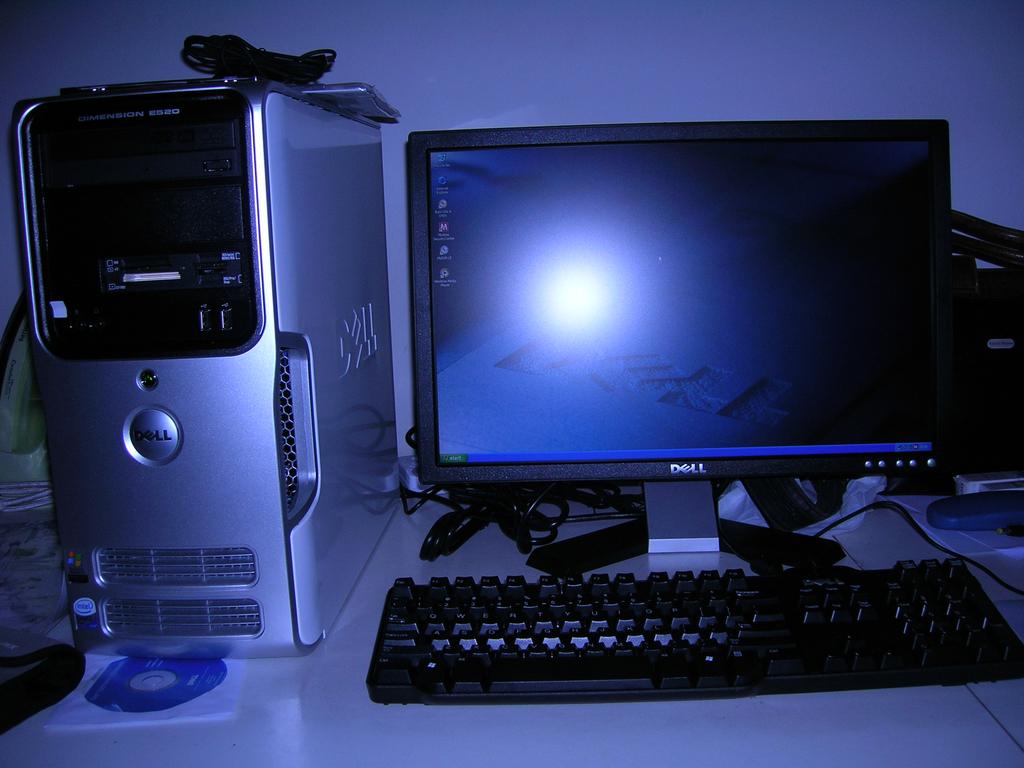What brand is the monitor?
Your response must be concise. Dell. What does it say in the bottom left corner of the monitor?
Keep it short and to the point. Start. 